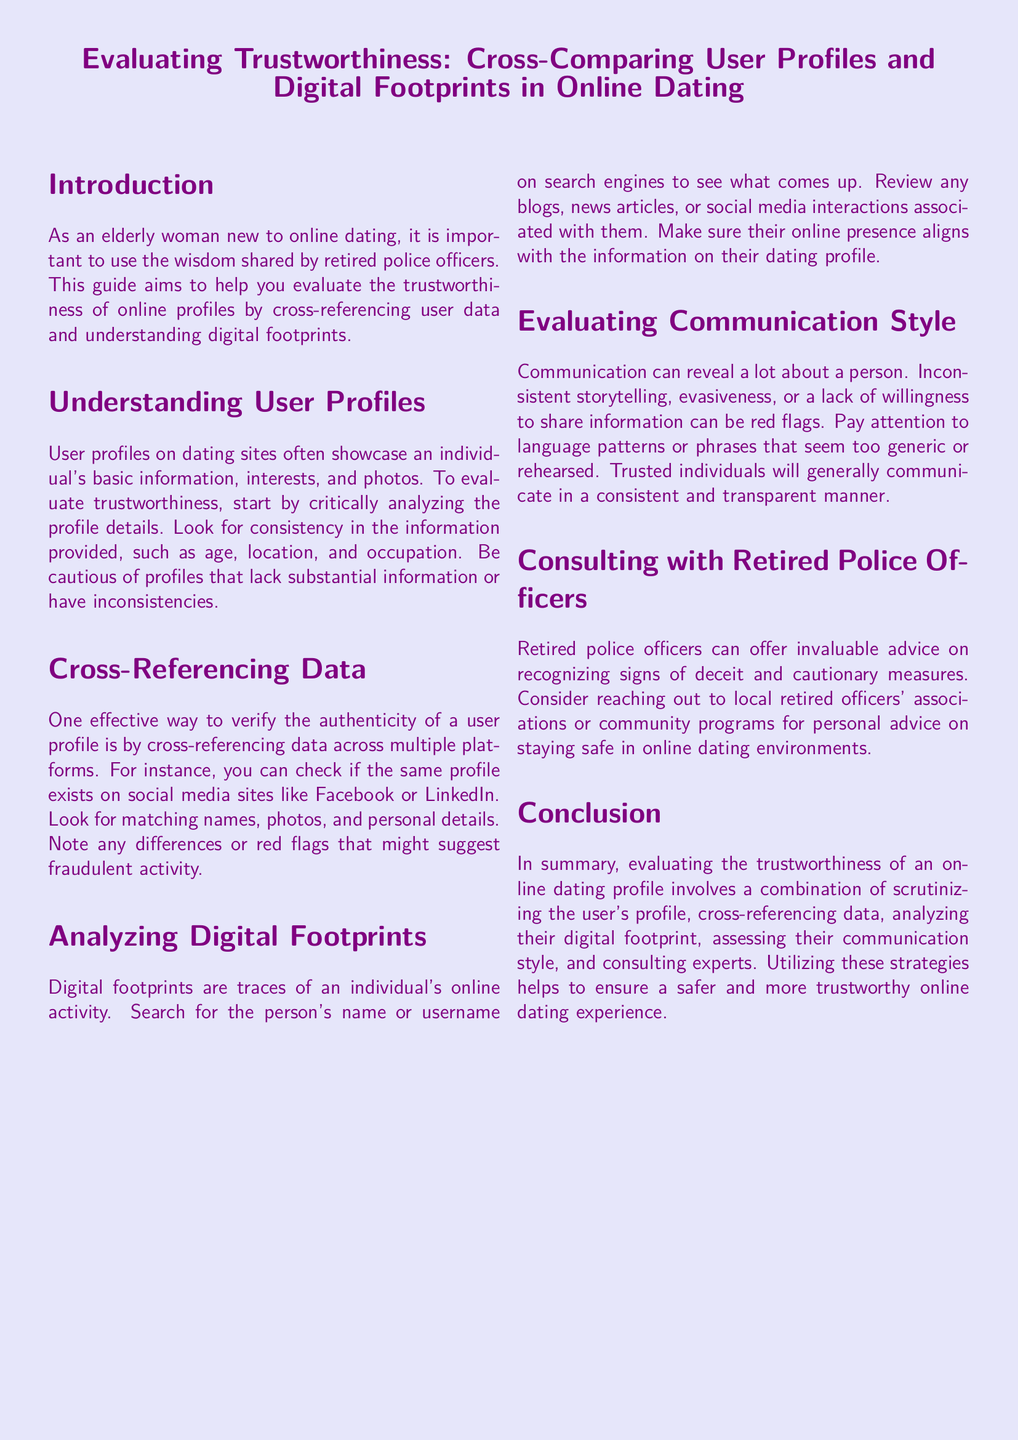what is the title of the document? The title summarizes the main focus of the document, which is about evaluating user profiles and digital footprints in online dating.
Answer: Evaluating Trustworthiness: Cross-Comparing User Profiles and Digital Footprints in Online Dating what is one method to verify user profiles? This method involves checking if the same profile appears on different platforms for consistency.
Answer: Cross-referencing data what should you look for in user profiles? Critical details to assess include age, location, and occupation to find consistency.
Answer: Consistency in information who can provide advice on recognizing deceit? This group is experienced in safety and can offer advice regarding online dating experiences.
Answer: Retired police officers what is the first step in evaluating trustworthiness? This step involves analyzing the details provided in the user profiles critically.
Answer: Critically analyzing profile details how can digital footprints be analyzed? Searching for an individual's name or username on search engines can help review their online presence.
Answer: Searching on search engines 